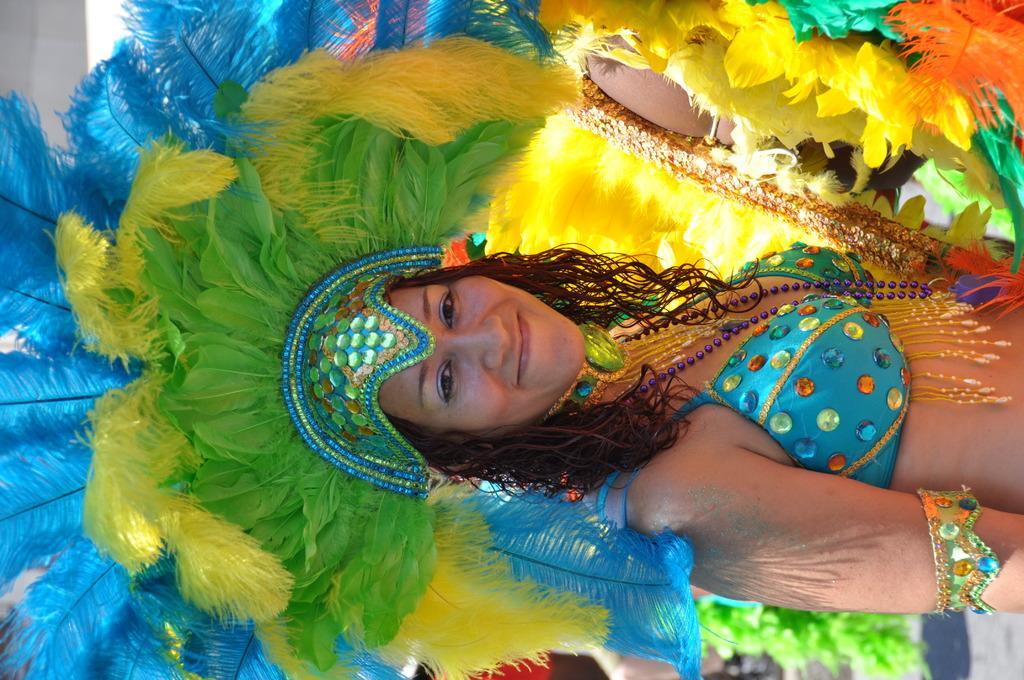How would you summarize this image in a sentence or two? Here we can see a woman in a fancy dress and she is smiling. 